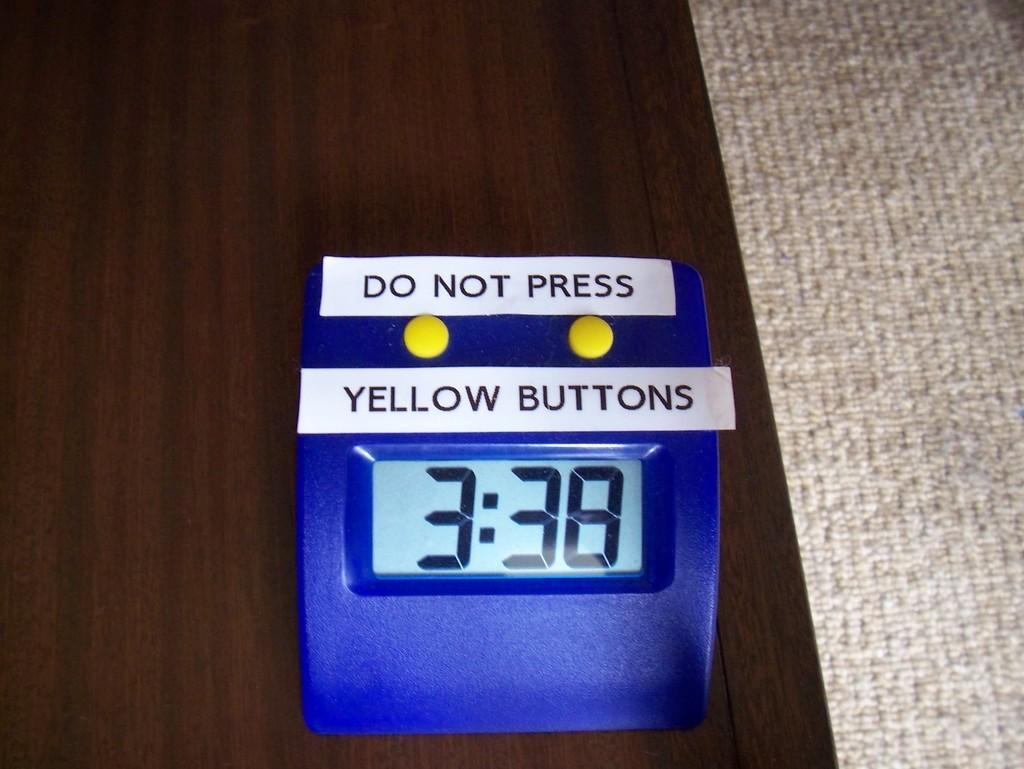<image>
Write a terse but informative summary of the picture. Blue digital clock that says 3:38 and telling people not to press yellow buttons. 